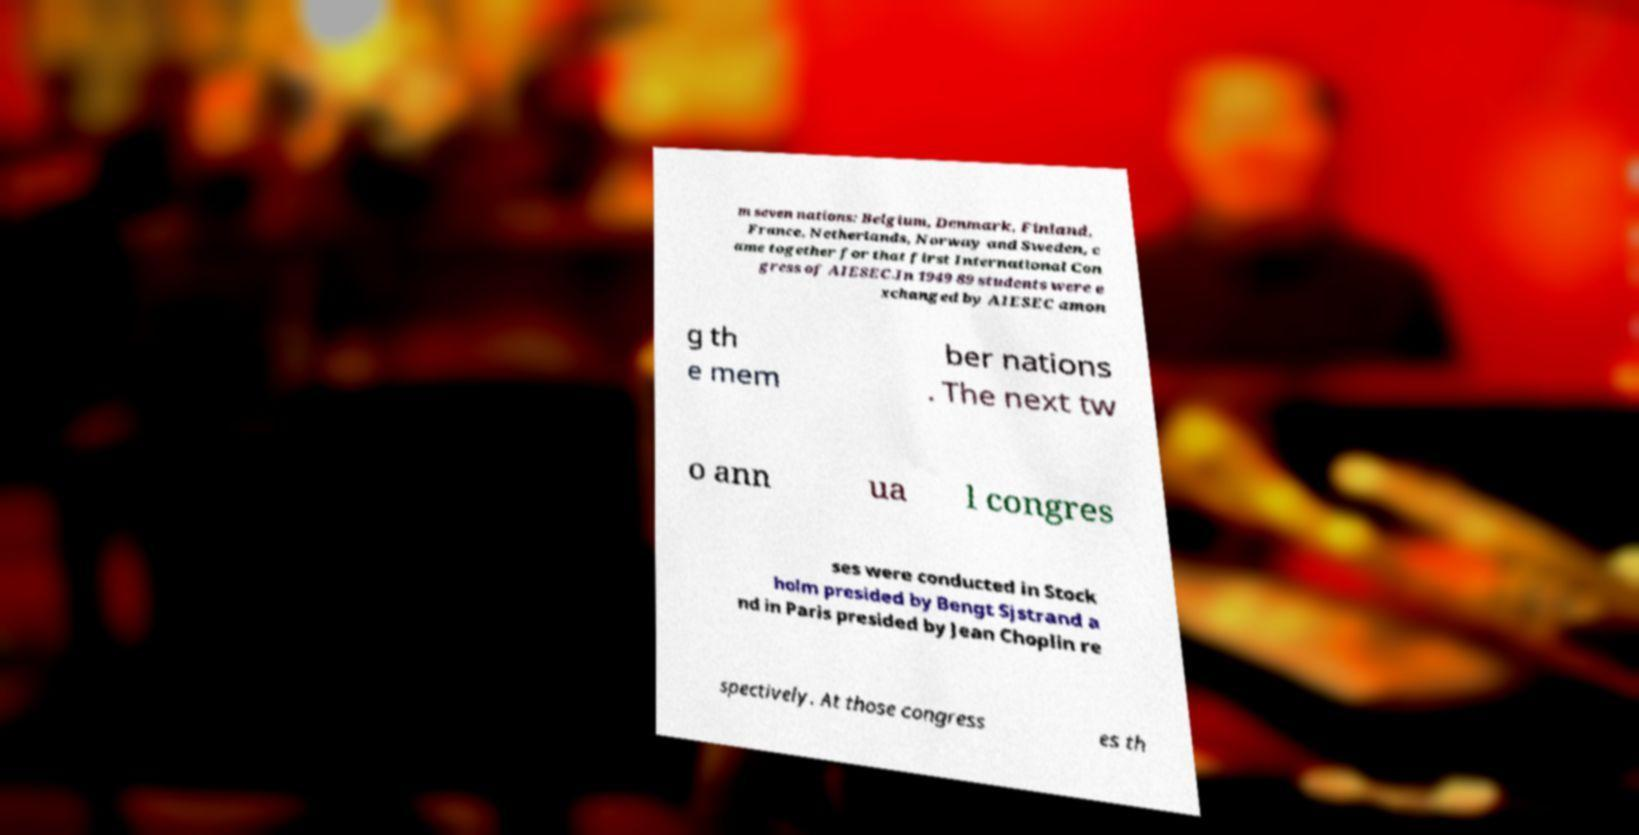Can you read and provide the text displayed in the image?This photo seems to have some interesting text. Can you extract and type it out for me? m seven nations: Belgium, Denmark, Finland, France, Netherlands, Norway and Sweden, c ame together for that first International Con gress of AIESEC.In 1949 89 students were e xchanged by AIESEC amon g th e mem ber nations . The next tw o ann ua l congres ses were conducted in Stock holm presided by Bengt Sjstrand a nd in Paris presided by Jean Choplin re spectively. At those congress es th 